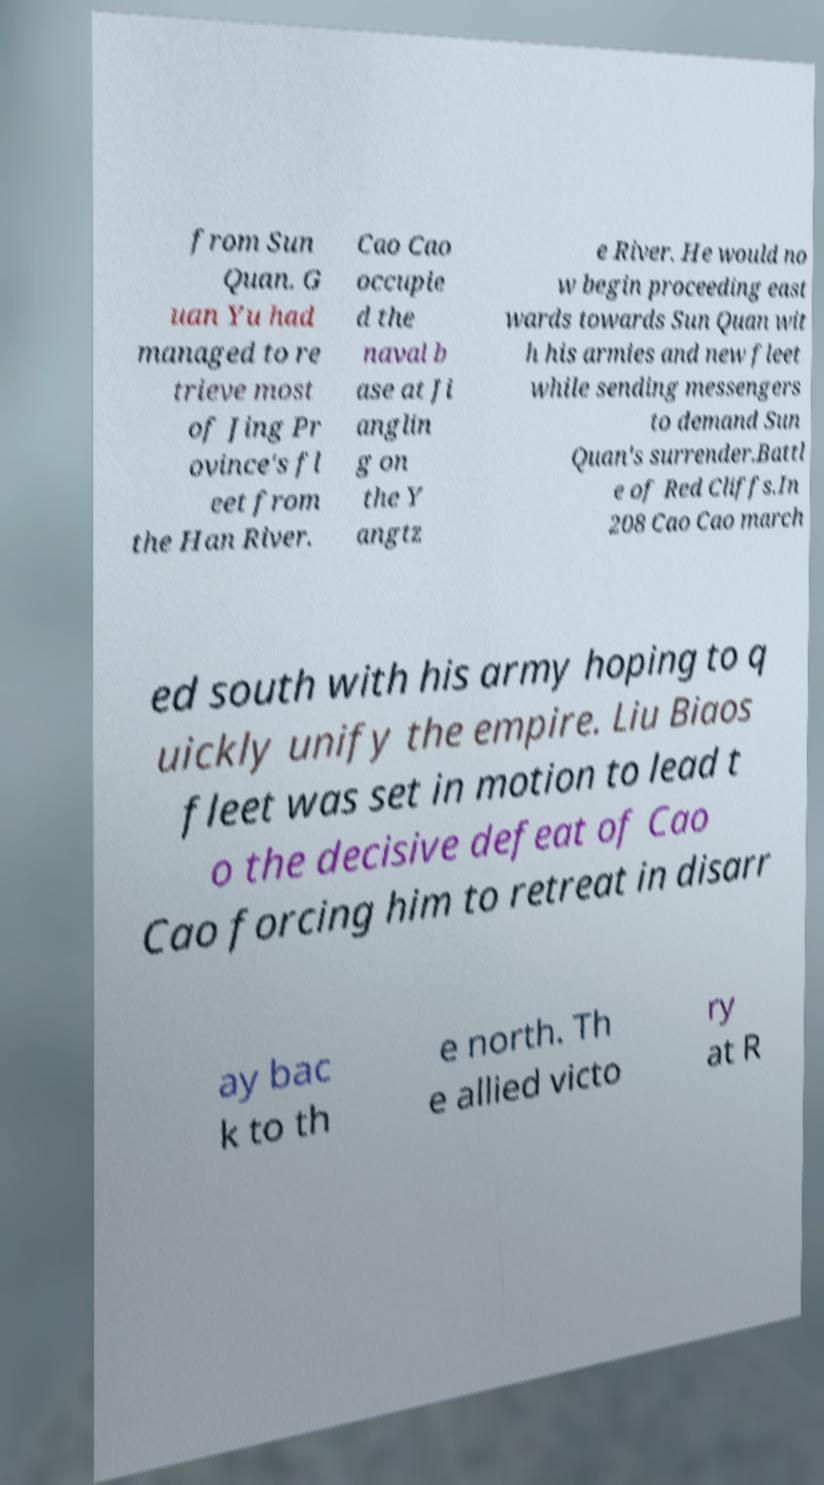Can you accurately transcribe the text from the provided image for me? from Sun Quan. G uan Yu had managed to re trieve most of Jing Pr ovince's fl eet from the Han River. Cao Cao occupie d the naval b ase at Ji anglin g on the Y angtz e River. He would no w begin proceeding east wards towards Sun Quan wit h his armies and new fleet while sending messengers to demand Sun Quan's surrender.Battl e of Red Cliffs.In 208 Cao Cao march ed south with his army hoping to q uickly unify the empire. Liu Biaos fleet was set in motion to lead t o the decisive defeat of Cao Cao forcing him to retreat in disarr ay bac k to th e north. Th e allied victo ry at R 